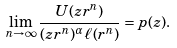Convert formula to latex. <formula><loc_0><loc_0><loc_500><loc_500>\lim _ { n \to \infty } \frac { U ( z r ^ { n } ) } { ( z r ^ { n } ) ^ { \alpha } \ell ( r ^ { n } ) } = p ( z ) .</formula> 